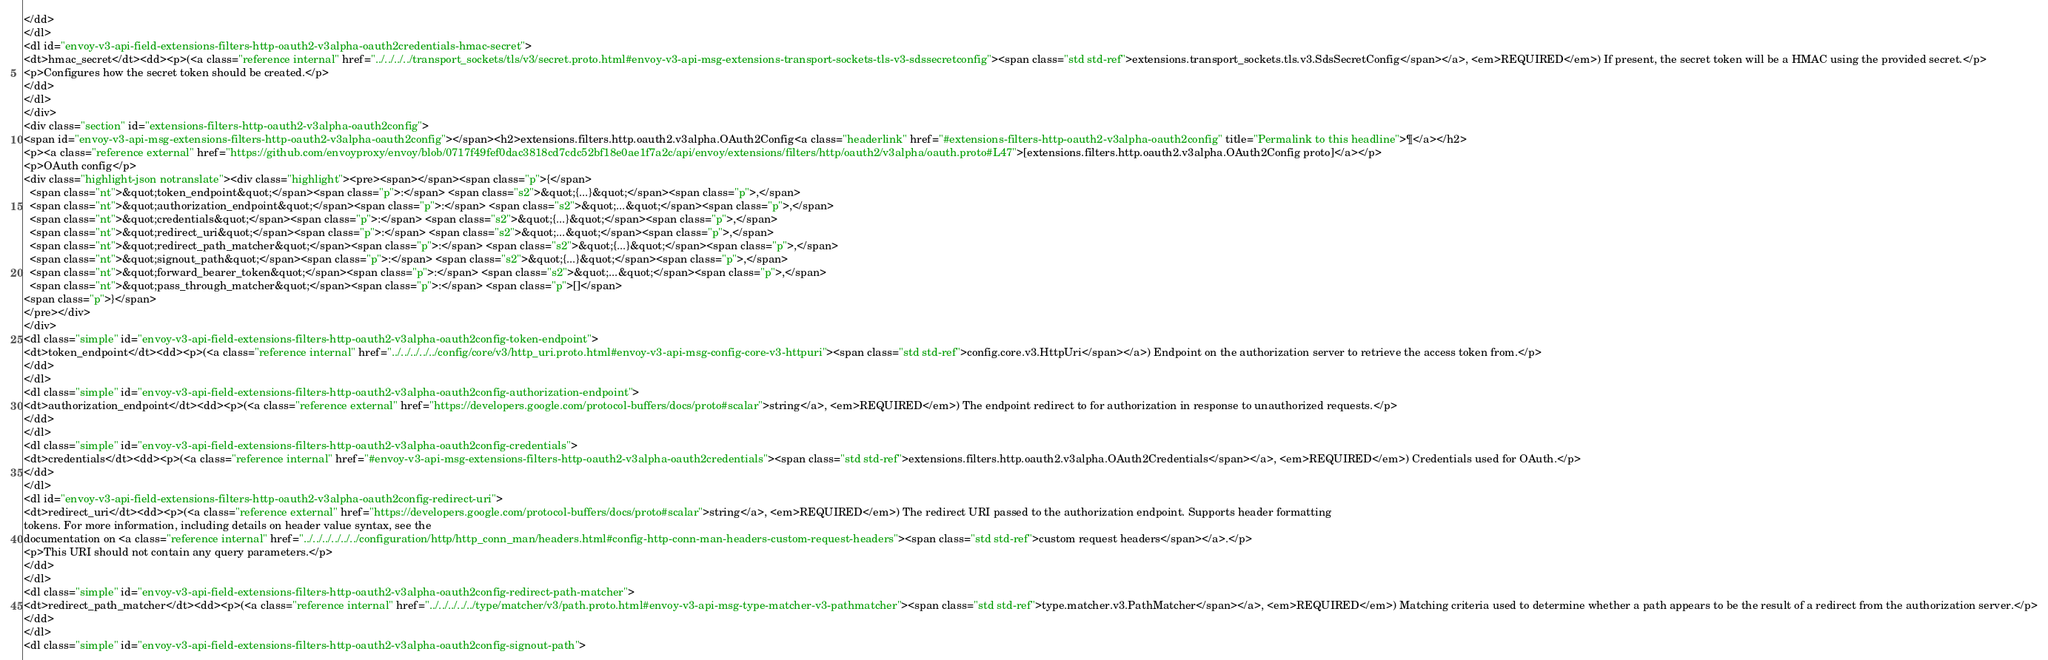<code> <loc_0><loc_0><loc_500><loc_500><_HTML_></dd>
</dl>
<dl id="envoy-v3-api-field-extensions-filters-http-oauth2-v3alpha-oauth2credentials-hmac-secret">
<dt>hmac_secret</dt><dd><p>(<a class="reference internal" href="../../../../transport_sockets/tls/v3/secret.proto.html#envoy-v3-api-msg-extensions-transport-sockets-tls-v3-sdssecretconfig"><span class="std std-ref">extensions.transport_sockets.tls.v3.SdsSecretConfig</span></a>, <em>REQUIRED</em>) If present, the secret token will be a HMAC using the provided secret.</p>
<p>Configures how the secret token should be created.</p>
</dd>
</dl>
</div>
<div class="section" id="extensions-filters-http-oauth2-v3alpha-oauth2config">
<span id="envoy-v3-api-msg-extensions-filters-http-oauth2-v3alpha-oauth2config"></span><h2>extensions.filters.http.oauth2.v3alpha.OAuth2Config<a class="headerlink" href="#extensions-filters-http-oauth2-v3alpha-oauth2config" title="Permalink to this headline">¶</a></h2>
<p><a class="reference external" href="https://github.com/envoyproxy/envoy/blob/0717f49fef0dac3818cd7cdc52bf18e0ae1f7a2c/api/envoy/extensions/filters/http/oauth2/v3alpha/oauth.proto#L47">[extensions.filters.http.oauth2.v3alpha.OAuth2Config proto]</a></p>
<p>OAuth config</p>
<div class="highlight-json notranslate"><div class="highlight"><pre><span></span><span class="p">{</span>
  <span class="nt">&quot;token_endpoint&quot;</span><span class="p">:</span> <span class="s2">&quot;{...}&quot;</span><span class="p">,</span>
  <span class="nt">&quot;authorization_endpoint&quot;</span><span class="p">:</span> <span class="s2">&quot;...&quot;</span><span class="p">,</span>
  <span class="nt">&quot;credentials&quot;</span><span class="p">:</span> <span class="s2">&quot;{...}&quot;</span><span class="p">,</span>
  <span class="nt">&quot;redirect_uri&quot;</span><span class="p">:</span> <span class="s2">&quot;...&quot;</span><span class="p">,</span>
  <span class="nt">&quot;redirect_path_matcher&quot;</span><span class="p">:</span> <span class="s2">&quot;{...}&quot;</span><span class="p">,</span>
  <span class="nt">&quot;signout_path&quot;</span><span class="p">:</span> <span class="s2">&quot;{...}&quot;</span><span class="p">,</span>
  <span class="nt">&quot;forward_bearer_token&quot;</span><span class="p">:</span> <span class="s2">&quot;...&quot;</span><span class="p">,</span>
  <span class="nt">&quot;pass_through_matcher&quot;</span><span class="p">:</span> <span class="p">[]</span>
<span class="p">}</span>
</pre></div>
</div>
<dl class="simple" id="envoy-v3-api-field-extensions-filters-http-oauth2-v3alpha-oauth2config-token-endpoint">
<dt>token_endpoint</dt><dd><p>(<a class="reference internal" href="../../../../../config/core/v3/http_uri.proto.html#envoy-v3-api-msg-config-core-v3-httpuri"><span class="std std-ref">config.core.v3.HttpUri</span></a>) Endpoint on the authorization server to retrieve the access token from.</p>
</dd>
</dl>
<dl class="simple" id="envoy-v3-api-field-extensions-filters-http-oauth2-v3alpha-oauth2config-authorization-endpoint">
<dt>authorization_endpoint</dt><dd><p>(<a class="reference external" href="https://developers.google.com/protocol-buffers/docs/proto#scalar">string</a>, <em>REQUIRED</em>) The endpoint redirect to for authorization in response to unauthorized requests.</p>
</dd>
</dl>
<dl class="simple" id="envoy-v3-api-field-extensions-filters-http-oauth2-v3alpha-oauth2config-credentials">
<dt>credentials</dt><dd><p>(<a class="reference internal" href="#envoy-v3-api-msg-extensions-filters-http-oauth2-v3alpha-oauth2credentials"><span class="std std-ref">extensions.filters.http.oauth2.v3alpha.OAuth2Credentials</span></a>, <em>REQUIRED</em>) Credentials used for OAuth.</p>
</dd>
</dl>
<dl id="envoy-v3-api-field-extensions-filters-http-oauth2-v3alpha-oauth2config-redirect-uri">
<dt>redirect_uri</dt><dd><p>(<a class="reference external" href="https://developers.google.com/protocol-buffers/docs/proto#scalar">string</a>, <em>REQUIRED</em>) The redirect URI passed to the authorization endpoint. Supports header formatting
tokens. For more information, including details on header value syntax, see the
documentation on <a class="reference internal" href="../../../../../../configuration/http/http_conn_man/headers.html#config-http-conn-man-headers-custom-request-headers"><span class="std std-ref">custom request headers</span></a>.</p>
<p>This URI should not contain any query parameters.</p>
</dd>
</dl>
<dl class="simple" id="envoy-v3-api-field-extensions-filters-http-oauth2-v3alpha-oauth2config-redirect-path-matcher">
<dt>redirect_path_matcher</dt><dd><p>(<a class="reference internal" href="../../../../../type/matcher/v3/path.proto.html#envoy-v3-api-msg-type-matcher-v3-pathmatcher"><span class="std std-ref">type.matcher.v3.PathMatcher</span></a>, <em>REQUIRED</em>) Matching criteria used to determine whether a path appears to be the result of a redirect from the authorization server.</p>
</dd>
</dl>
<dl class="simple" id="envoy-v3-api-field-extensions-filters-http-oauth2-v3alpha-oauth2config-signout-path"></code> 